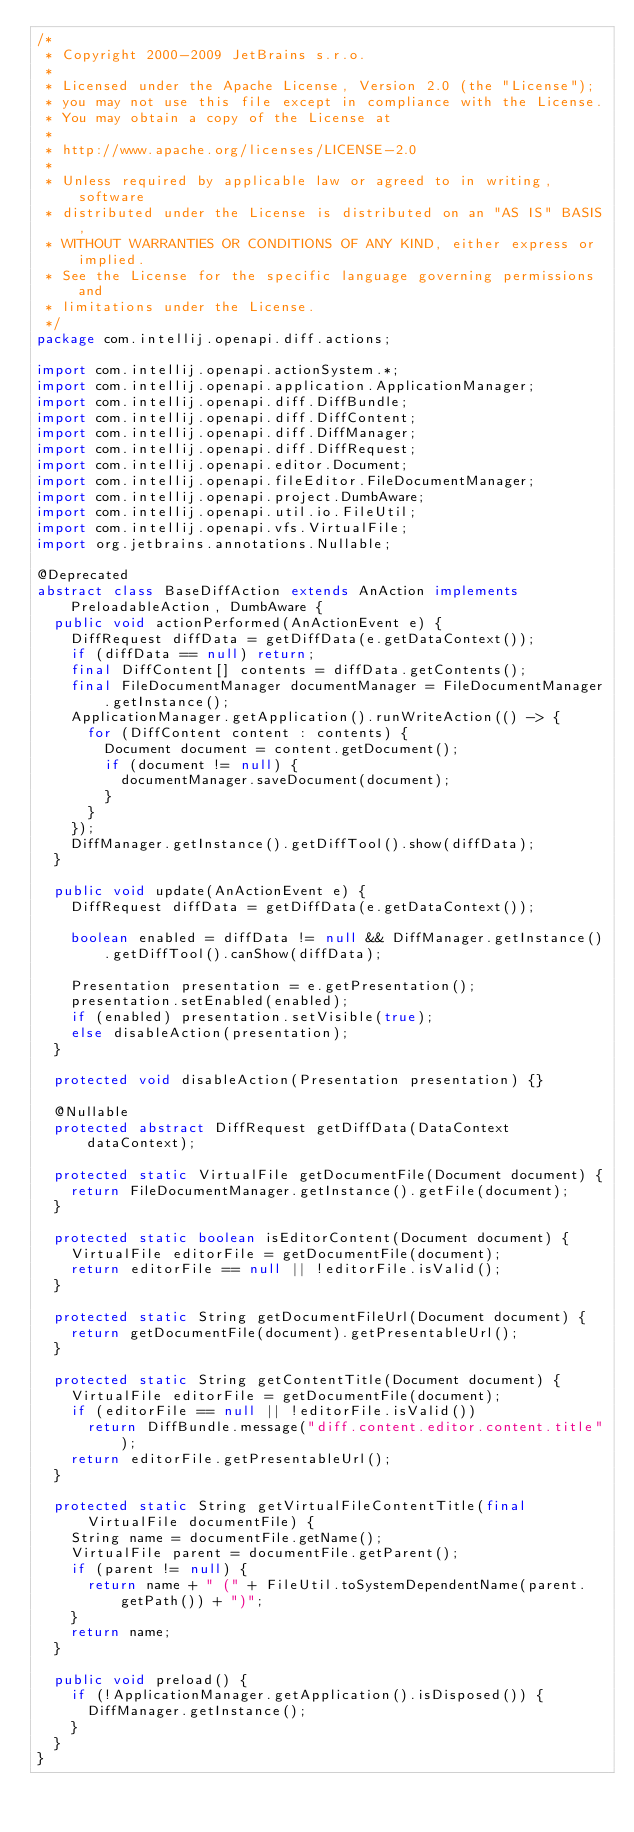Convert code to text. <code><loc_0><loc_0><loc_500><loc_500><_Java_>/*
 * Copyright 2000-2009 JetBrains s.r.o.
 *
 * Licensed under the Apache License, Version 2.0 (the "License");
 * you may not use this file except in compliance with the License.
 * You may obtain a copy of the License at
 *
 * http://www.apache.org/licenses/LICENSE-2.0
 *
 * Unless required by applicable law or agreed to in writing, software
 * distributed under the License is distributed on an "AS IS" BASIS,
 * WITHOUT WARRANTIES OR CONDITIONS OF ANY KIND, either express or implied.
 * See the License for the specific language governing permissions and
 * limitations under the License.
 */
package com.intellij.openapi.diff.actions;

import com.intellij.openapi.actionSystem.*;
import com.intellij.openapi.application.ApplicationManager;
import com.intellij.openapi.diff.DiffBundle;
import com.intellij.openapi.diff.DiffContent;
import com.intellij.openapi.diff.DiffManager;
import com.intellij.openapi.diff.DiffRequest;
import com.intellij.openapi.editor.Document;
import com.intellij.openapi.fileEditor.FileDocumentManager;
import com.intellij.openapi.project.DumbAware;
import com.intellij.openapi.util.io.FileUtil;
import com.intellij.openapi.vfs.VirtualFile;
import org.jetbrains.annotations.Nullable;

@Deprecated
abstract class BaseDiffAction extends AnAction implements PreloadableAction, DumbAware {
  public void actionPerformed(AnActionEvent e) {
    DiffRequest diffData = getDiffData(e.getDataContext());
    if (diffData == null) return;
    final DiffContent[] contents = diffData.getContents();
    final FileDocumentManager documentManager = FileDocumentManager.getInstance();
    ApplicationManager.getApplication().runWriteAction(() -> {
      for (DiffContent content : contents) {
        Document document = content.getDocument();
        if (document != null) {
          documentManager.saveDocument(document);
        }
      }
    });
    DiffManager.getInstance().getDiffTool().show(diffData);
  }

  public void update(AnActionEvent e) {
    DiffRequest diffData = getDiffData(e.getDataContext());

    boolean enabled = diffData != null && DiffManager.getInstance().getDiffTool().canShow(diffData);

    Presentation presentation = e.getPresentation();
    presentation.setEnabled(enabled);
    if (enabled) presentation.setVisible(true);
    else disableAction(presentation);
  }

  protected void disableAction(Presentation presentation) {}

  @Nullable
  protected abstract DiffRequest getDiffData(DataContext dataContext);

  protected static VirtualFile getDocumentFile(Document document) {
    return FileDocumentManager.getInstance().getFile(document);
  }

  protected static boolean isEditorContent(Document document) {
    VirtualFile editorFile = getDocumentFile(document);
    return editorFile == null || !editorFile.isValid();
  }

  protected static String getDocumentFileUrl(Document document) {
    return getDocumentFile(document).getPresentableUrl();
  }

  protected static String getContentTitle(Document document) {
    VirtualFile editorFile = getDocumentFile(document);
    if (editorFile == null || !editorFile.isValid())
      return DiffBundle.message("diff.content.editor.content.title");
    return editorFile.getPresentableUrl();
  }

  protected static String getVirtualFileContentTitle(final VirtualFile documentFile) {
    String name = documentFile.getName();
    VirtualFile parent = documentFile.getParent();
    if (parent != null) {
      return name + " (" + FileUtil.toSystemDependentName(parent.getPath()) + ")";
    }
    return name;
  }

  public void preload() {
    if (!ApplicationManager.getApplication().isDisposed()) {
      DiffManager.getInstance();
    }
  }
}
</code> 